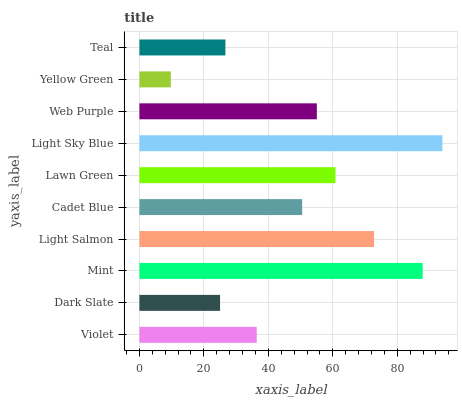Is Yellow Green the minimum?
Answer yes or no. Yes. Is Light Sky Blue the maximum?
Answer yes or no. Yes. Is Dark Slate the minimum?
Answer yes or no. No. Is Dark Slate the maximum?
Answer yes or no. No. Is Violet greater than Dark Slate?
Answer yes or no. Yes. Is Dark Slate less than Violet?
Answer yes or no. Yes. Is Dark Slate greater than Violet?
Answer yes or no. No. Is Violet less than Dark Slate?
Answer yes or no. No. Is Web Purple the high median?
Answer yes or no. Yes. Is Cadet Blue the low median?
Answer yes or no. Yes. Is Light Sky Blue the high median?
Answer yes or no. No. Is Violet the low median?
Answer yes or no. No. 